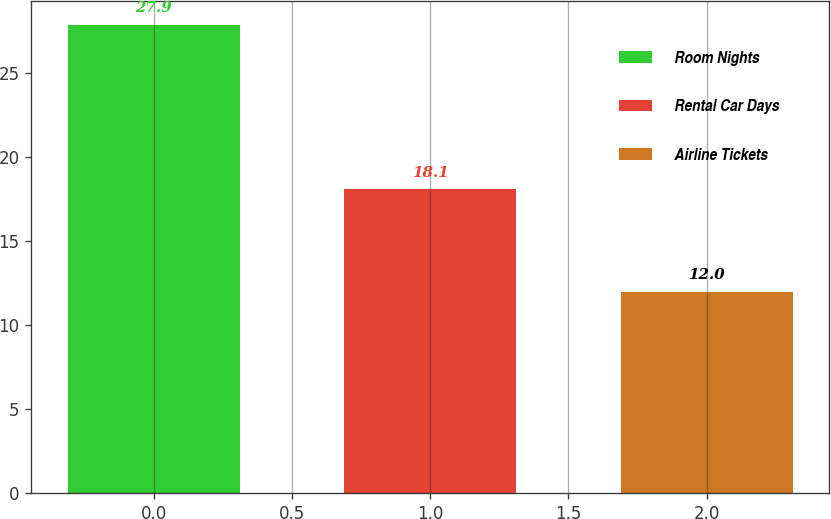Convert chart to OTSL. <chart><loc_0><loc_0><loc_500><loc_500><bar_chart><fcel>Room Nights<fcel>Rental Car Days<fcel>Airline Tickets<nl><fcel>27.9<fcel>18.1<fcel>12<nl></chart> 